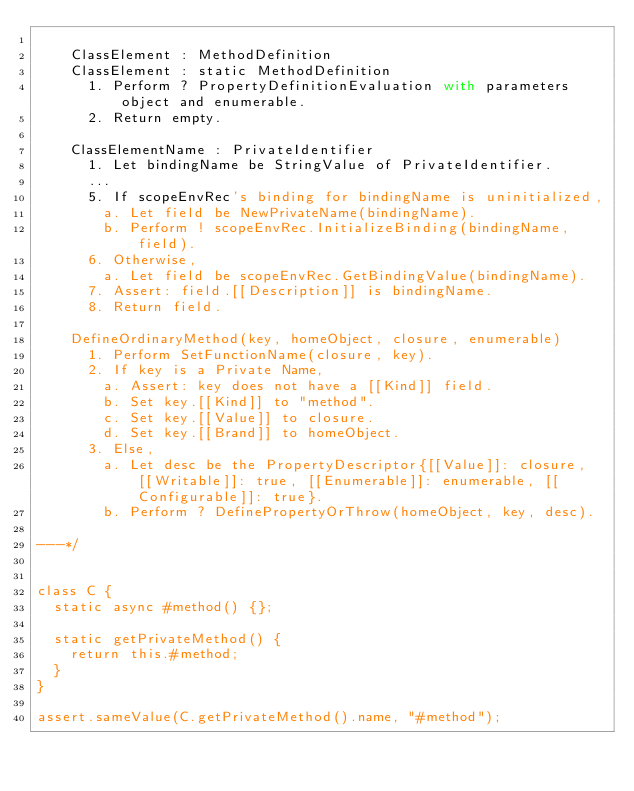<code> <loc_0><loc_0><loc_500><loc_500><_JavaScript_>
    ClassElement : MethodDefinition
    ClassElement : static MethodDefinition
      1. Perform ? PropertyDefinitionEvaluation with parameters object and enumerable.
      2. Return empty.

    ClassElementName : PrivateIdentifier
      1. Let bindingName be StringValue of PrivateIdentifier.
      ...
      5. If scopeEnvRec's binding for bindingName is uninitialized,
        a. Let field be NewPrivateName(bindingName).
        b. Perform ! scopeEnvRec.InitializeBinding(bindingName, field).
      6. Otherwise,
        a. Let field be scopeEnvRec.GetBindingValue(bindingName).
      7. Assert: field.[[Description]] is bindingName.
      8. Return field.

    DefineOrdinaryMethod(key, homeObject, closure, enumerable)
      1. Perform SetFunctionName(closure, key).
      2. If key is a Private Name,
        a. Assert: key does not have a [[Kind]] field.
        b. Set key.[[Kind]] to "method".
        c. Set key.[[Value]] to closure.
        d. Set key.[[Brand]] to homeObject.
      3. Else,
        a. Let desc be the PropertyDescriptor{[[Value]]: closure, [[Writable]]: true, [[Enumerable]]: enumerable, [[Configurable]]: true}.
        b. Perform ? DefinePropertyOrThrow(homeObject, key, desc).

---*/


class C {
  static async #method() {};

  static getPrivateMethod() {
    return this.#method;
  }
}

assert.sameValue(C.getPrivateMethod().name, "#method");
</code> 